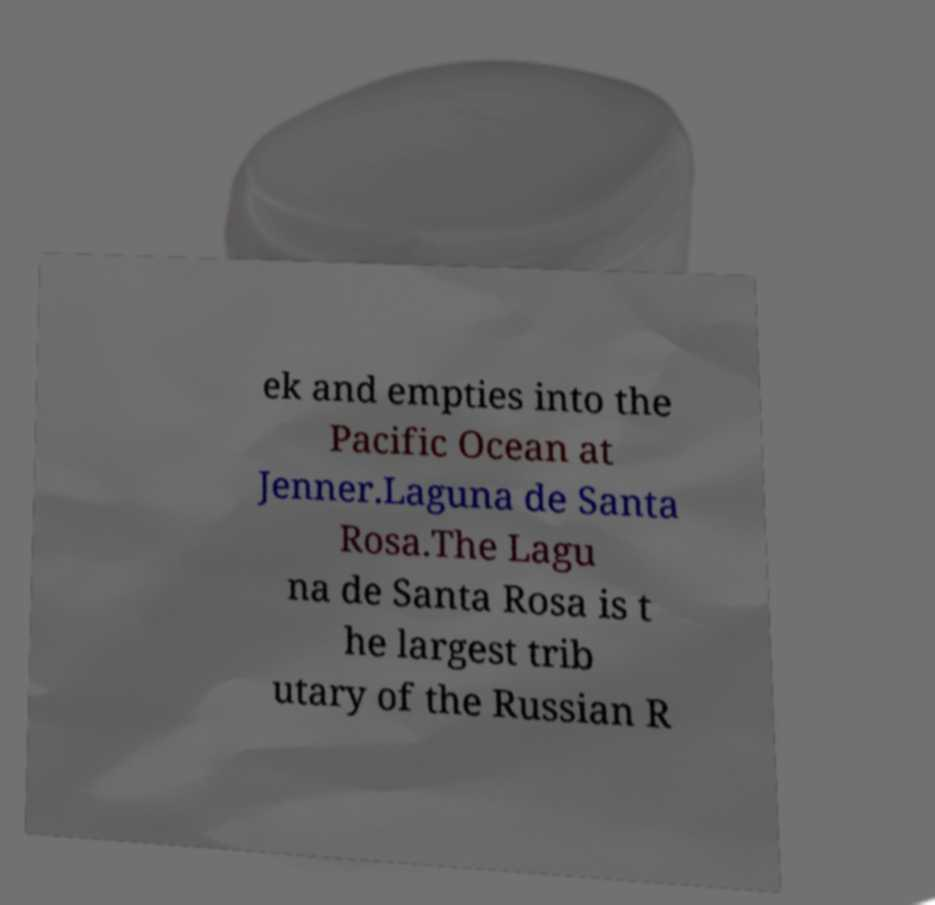For documentation purposes, I need the text within this image transcribed. Could you provide that? ek and empties into the Pacific Ocean at Jenner.Laguna de Santa Rosa.The Lagu na de Santa Rosa is t he largest trib utary of the Russian R 